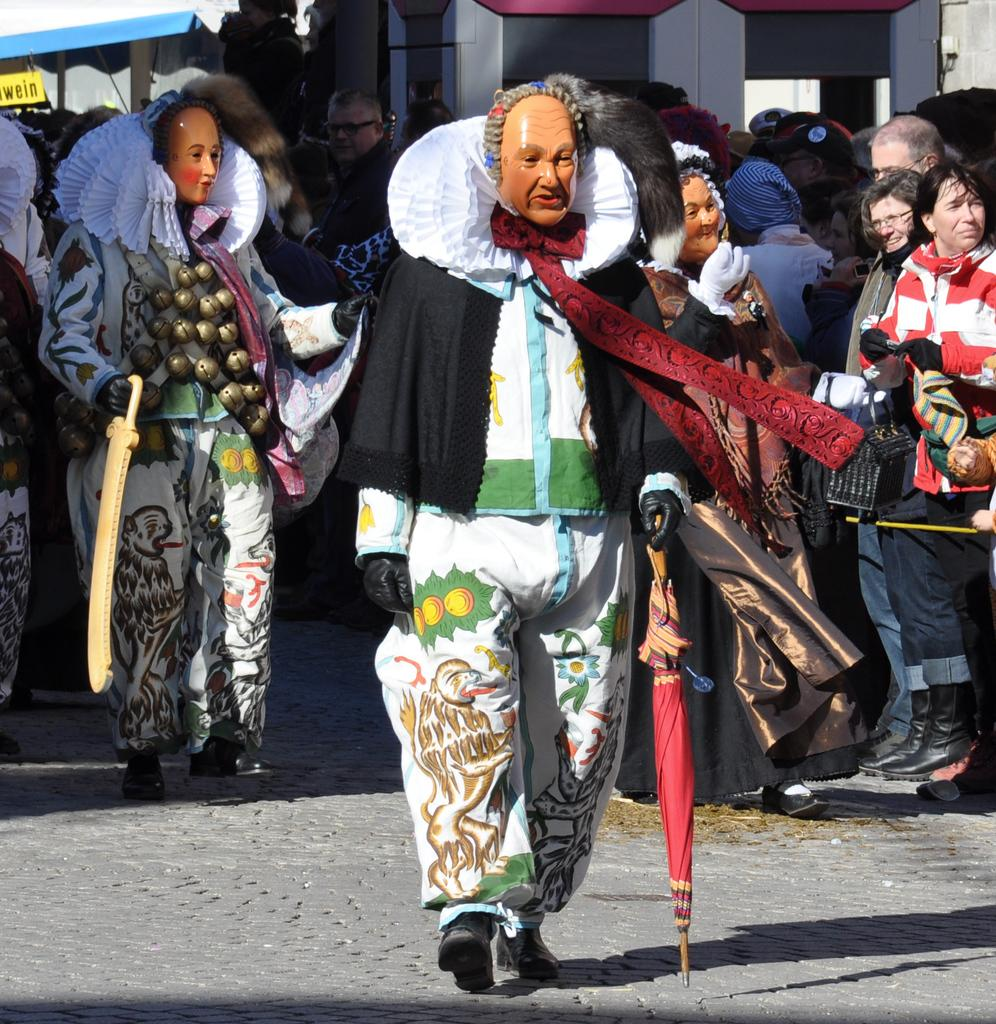What are the people in the image wearing? The people in the image are wearing costumes. How many people can be seen in the image? There are many people in the background of the image. What can be seen in the distance behind the people? There is a building in the background of the image. What type of chair is being used by the moon in the image? There is no chair or moon present in the image. 